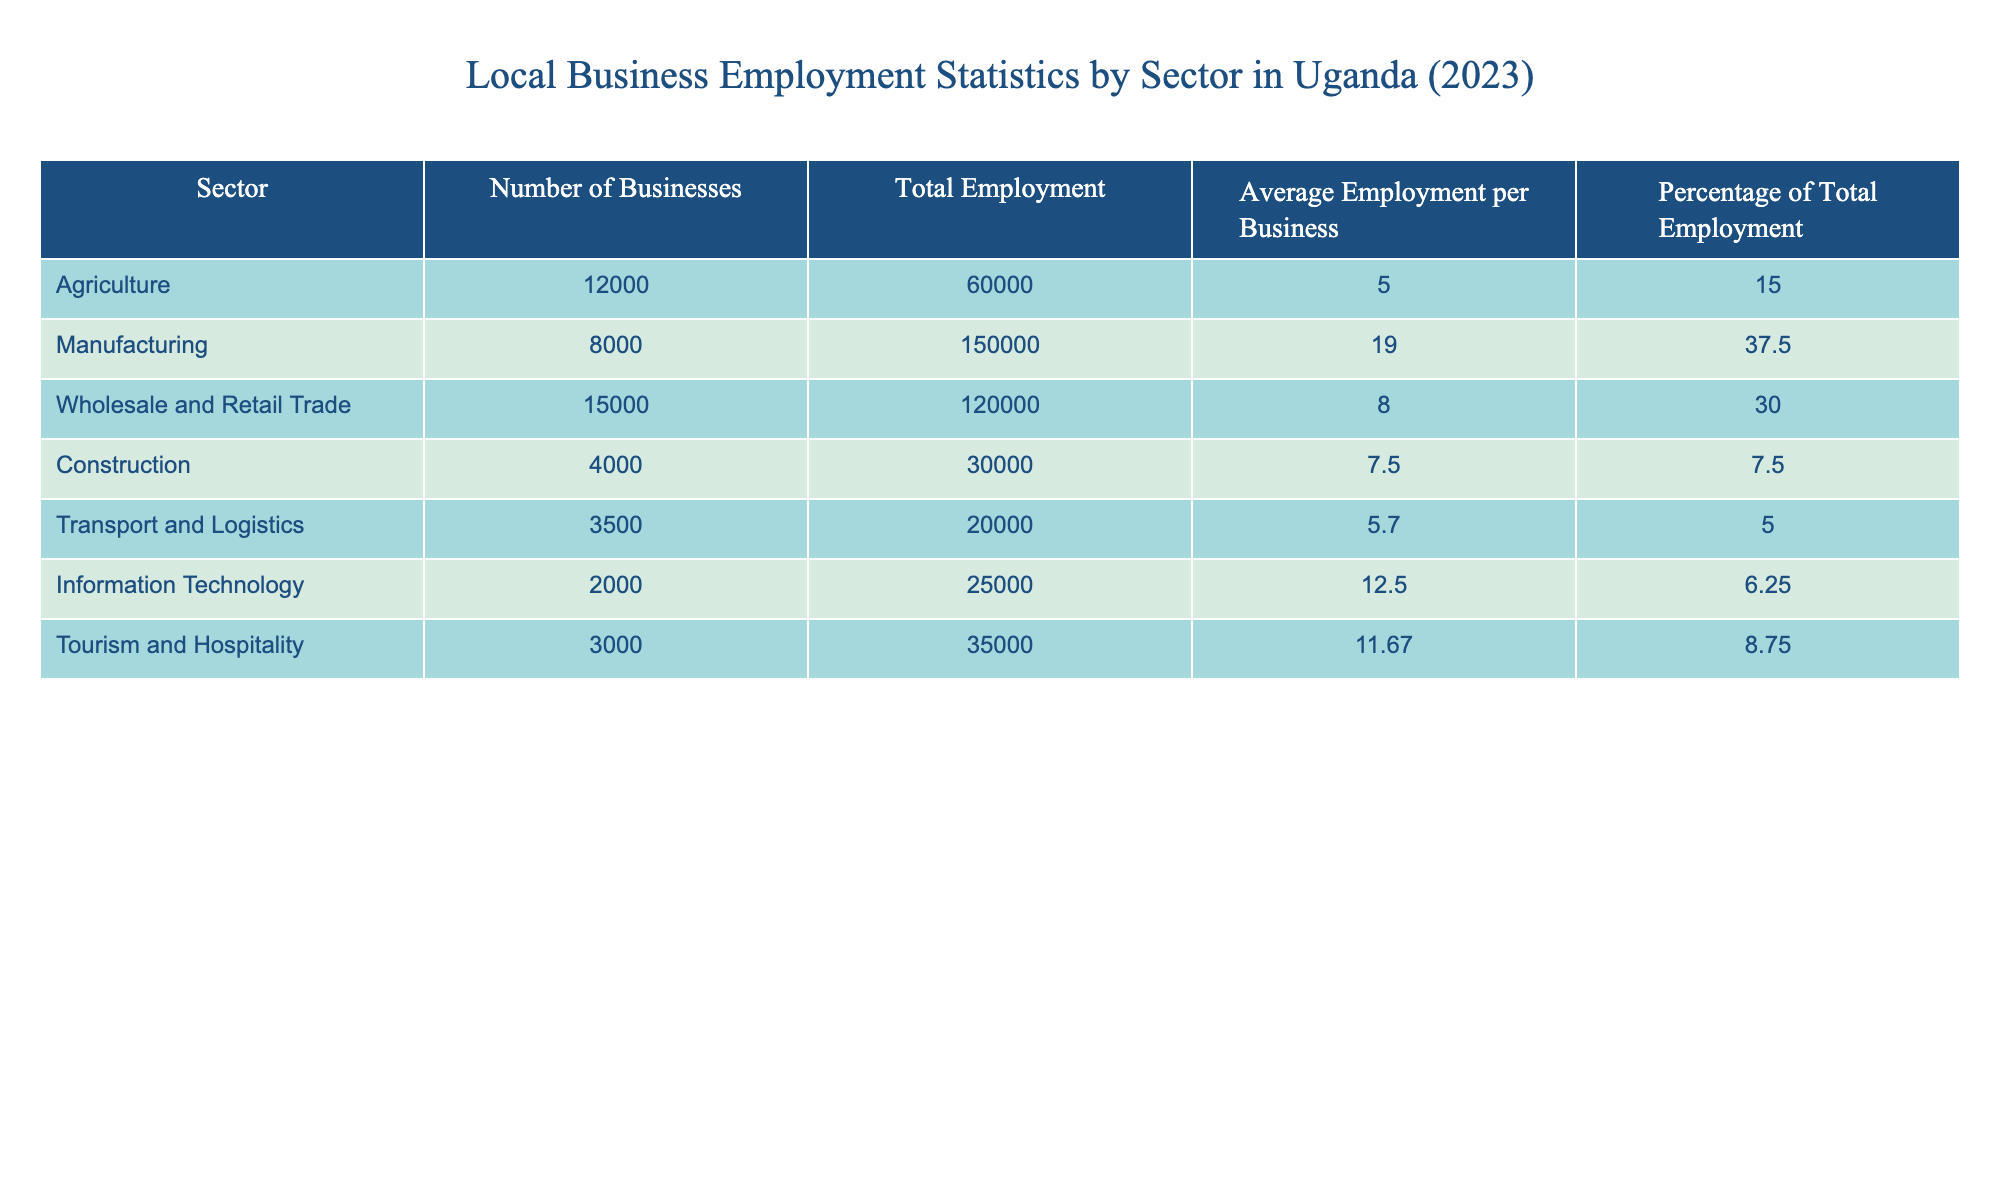What is the total employment in the Manufacturing sector? The table shows that the total employment in the Manufacturing sector is explicitly listed under the "Total Employment" column. From the table, the value for Manufacturing is 150,000.
Answer: 150000 Which sector has the highest average employment per business? By looking at the "Average Employment per Business" column, the highest value is 19, which corresponds to the Manufacturing sector. Hence, Manufacturing has the highest average employment per business.
Answer: Manufacturing What is the total number of businesses in the Wholesale and Retail Trade sector? The table directly provides the number of businesses in the Wholesale and Retail Trade sector. The corresponding value is 15,000, found in the "Number of Businesses" column.
Answer: 15000 Is the total employment in the Construction sector more than the total employment in the Transport and Logistics sector? The total employment for Construction is 30,000 and for Transport and Logistics is 20,000, respectively. Since 30,000 is greater than 20,000, the statement is true.
Answer: Yes What percentage of total employment does the Agriculture sector represent? The table states that the Agriculture sector accounts for 15% of the total employment, as indicated in the "Percentage of Total Employment" column.
Answer: 15% How many total businesses are there in sectors with more than 20,000 total employment? The sectors with more than 20,000 total employment are Manufacturing (8,000), Wholesale and Retail Trade (15,000), and Tourism and Hospitality (3,000). Adding these gives 8,000 + 15,000 + 3,000 = 26,000 total businesses across those sectors.
Answer: 26000 What is the combined total employment of the Agriculture and Construction sectors? The total employment in Agriculture is 60,000 and in Construction is 30,000. Combining these, we add them together: 60,000 + 30,000 = 90,000 for the two sectors combined.
Answer: 90000 Does the Information Technology sector have more businesses than the Transport and Logistics sector? The number of businesses in Information Technology is 2,000, while for Transport and Logistics it is 3,500. Since 2,000 is less than 3,500, this statement is false.
Answer: No Which sector contributes the least to total employment based on the table? By examining the "Total Employment" column, we find that the Transport and Logistics sector has the lowest total employment listed, which is 20,000.
Answer: Transport and Logistics 